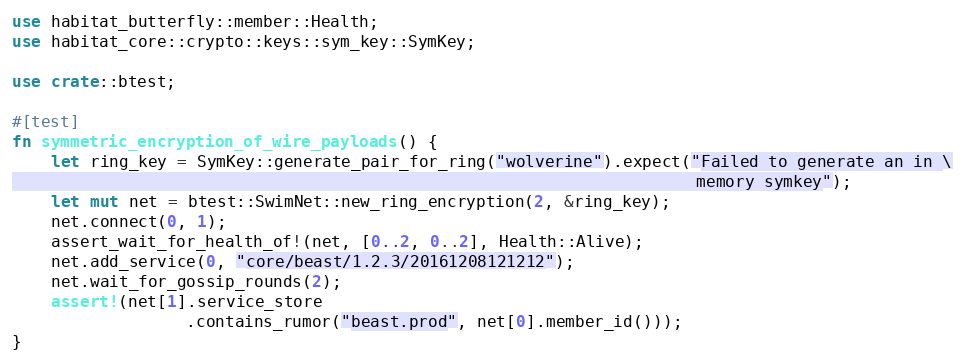<code> <loc_0><loc_0><loc_500><loc_500><_Rust_>use habitat_butterfly::member::Health;
use habitat_core::crypto::keys::sym_key::SymKey;

use crate::btest;

#[test]
fn symmetric_encryption_of_wire_payloads() {
    let ring_key = SymKey::generate_pair_for_ring("wolverine").expect("Failed to generate an in \
                                                                       memory symkey");
    let mut net = btest::SwimNet::new_ring_encryption(2, &ring_key);
    net.connect(0, 1);
    assert_wait_for_health_of!(net, [0..2, 0..2], Health::Alive);
    net.add_service(0, "core/beast/1.2.3/20161208121212");
    net.wait_for_gossip_rounds(2);
    assert!(net[1].service_store
                  .contains_rumor("beast.prod", net[0].member_id()));
}
</code> 